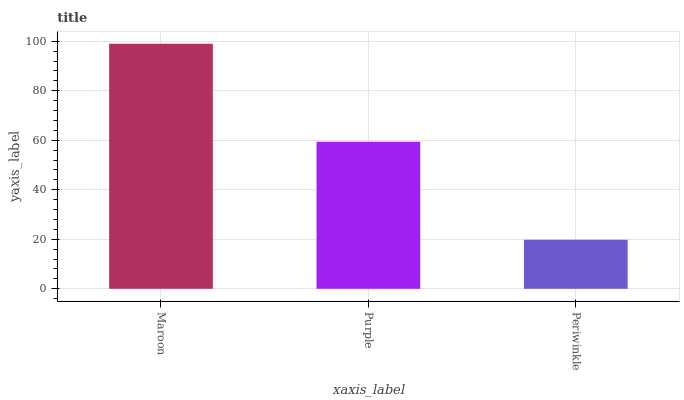Is Periwinkle the minimum?
Answer yes or no. Yes. Is Maroon the maximum?
Answer yes or no. Yes. Is Purple the minimum?
Answer yes or no. No. Is Purple the maximum?
Answer yes or no. No. Is Maroon greater than Purple?
Answer yes or no. Yes. Is Purple less than Maroon?
Answer yes or no. Yes. Is Purple greater than Maroon?
Answer yes or no. No. Is Maroon less than Purple?
Answer yes or no. No. Is Purple the high median?
Answer yes or no. Yes. Is Purple the low median?
Answer yes or no. Yes. Is Maroon the high median?
Answer yes or no. No. Is Periwinkle the low median?
Answer yes or no. No. 